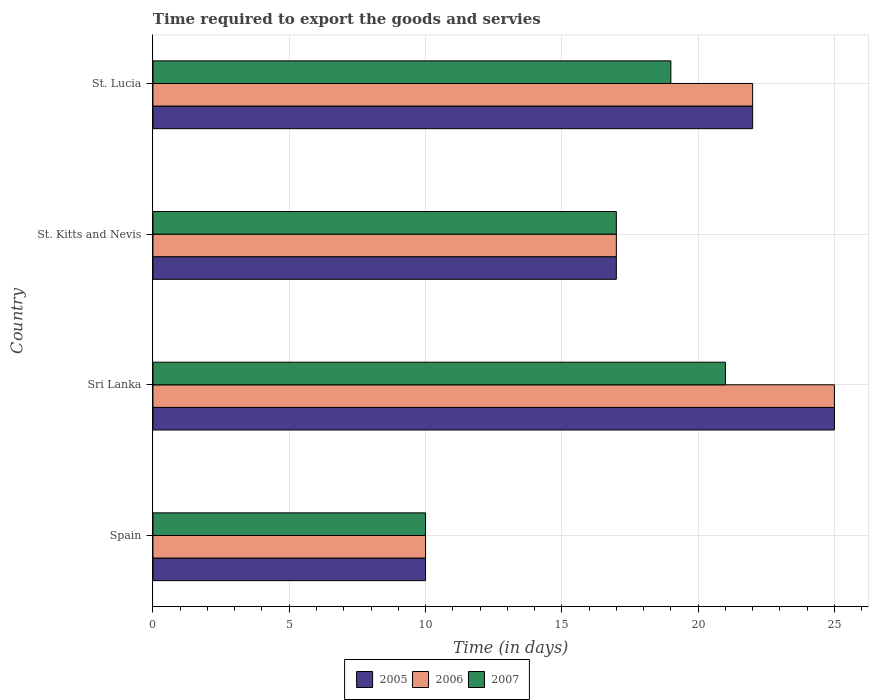How many groups of bars are there?
Keep it short and to the point. 4. Are the number of bars per tick equal to the number of legend labels?
Make the answer very short. Yes. Are the number of bars on each tick of the Y-axis equal?
Your response must be concise. Yes. How many bars are there on the 1st tick from the top?
Offer a terse response. 3. What is the label of the 3rd group of bars from the top?
Your answer should be very brief. Sri Lanka. In how many cases, is the number of bars for a given country not equal to the number of legend labels?
Your answer should be very brief. 0. Across all countries, what is the maximum number of days required to export the goods and services in 2006?
Make the answer very short. 25. Across all countries, what is the minimum number of days required to export the goods and services in 2005?
Provide a short and direct response. 10. In which country was the number of days required to export the goods and services in 2006 maximum?
Your answer should be compact. Sri Lanka. What is the difference between the number of days required to export the goods and services in 2005 in Spain and the number of days required to export the goods and services in 2007 in St. Kitts and Nevis?
Your answer should be compact. -7. What is the average number of days required to export the goods and services in 2005 per country?
Provide a short and direct response. 18.5. What is the difference between the number of days required to export the goods and services in 2006 and number of days required to export the goods and services in 2007 in Sri Lanka?
Provide a succinct answer. 4. In how many countries, is the number of days required to export the goods and services in 2006 greater than 12 days?
Provide a short and direct response. 3. What is the ratio of the number of days required to export the goods and services in 2007 in St. Kitts and Nevis to that in St. Lucia?
Your answer should be compact. 0.89. Is the number of days required to export the goods and services in 2005 in Spain less than that in St. Lucia?
Keep it short and to the point. Yes. What is the difference between the highest and the second highest number of days required to export the goods and services in 2005?
Your answer should be very brief. 3. What is the difference between the highest and the lowest number of days required to export the goods and services in 2005?
Provide a succinct answer. 15. In how many countries, is the number of days required to export the goods and services in 2006 greater than the average number of days required to export the goods and services in 2006 taken over all countries?
Ensure brevity in your answer.  2. Is the sum of the number of days required to export the goods and services in 2007 in Sri Lanka and St. Lucia greater than the maximum number of days required to export the goods and services in 2005 across all countries?
Offer a terse response. Yes. What does the 1st bar from the top in Sri Lanka represents?
Offer a terse response. 2007. What is the difference between two consecutive major ticks on the X-axis?
Your response must be concise. 5. Are the values on the major ticks of X-axis written in scientific E-notation?
Provide a succinct answer. No. What is the title of the graph?
Keep it short and to the point. Time required to export the goods and servies. Does "2012" appear as one of the legend labels in the graph?
Give a very brief answer. No. What is the label or title of the X-axis?
Your response must be concise. Time (in days). What is the label or title of the Y-axis?
Your answer should be compact. Country. What is the Time (in days) in 2005 in Spain?
Your answer should be very brief. 10. What is the Time (in days) of 2006 in Spain?
Your response must be concise. 10. What is the Time (in days) of 2007 in Spain?
Make the answer very short. 10. What is the Time (in days) of 2005 in Sri Lanka?
Make the answer very short. 25. What is the Time (in days) in 2006 in Sri Lanka?
Give a very brief answer. 25. What is the Time (in days) in 2006 in St. Kitts and Nevis?
Provide a short and direct response. 17. What is the Time (in days) in 2006 in St. Lucia?
Keep it short and to the point. 22. What is the Time (in days) of 2007 in St. Lucia?
Ensure brevity in your answer.  19. Across all countries, what is the minimum Time (in days) of 2006?
Your answer should be very brief. 10. Across all countries, what is the minimum Time (in days) of 2007?
Make the answer very short. 10. What is the total Time (in days) of 2005 in the graph?
Provide a short and direct response. 74. What is the total Time (in days) of 2006 in the graph?
Provide a succinct answer. 74. What is the total Time (in days) of 2007 in the graph?
Make the answer very short. 67. What is the difference between the Time (in days) in 2005 in Spain and that in Sri Lanka?
Offer a very short reply. -15. What is the difference between the Time (in days) of 2006 in Spain and that in Sri Lanka?
Give a very brief answer. -15. What is the difference between the Time (in days) of 2005 in Spain and that in St. Kitts and Nevis?
Give a very brief answer. -7. What is the difference between the Time (in days) in 2007 in Spain and that in St. Kitts and Nevis?
Provide a short and direct response. -7. What is the difference between the Time (in days) in 2005 in Spain and that in St. Lucia?
Make the answer very short. -12. What is the difference between the Time (in days) in 2007 in Sri Lanka and that in St. Lucia?
Offer a terse response. 2. What is the difference between the Time (in days) in 2005 in St. Kitts and Nevis and that in St. Lucia?
Your answer should be very brief. -5. What is the difference between the Time (in days) of 2006 in St. Kitts and Nevis and that in St. Lucia?
Keep it short and to the point. -5. What is the difference between the Time (in days) of 2005 in Spain and the Time (in days) of 2006 in Sri Lanka?
Offer a terse response. -15. What is the difference between the Time (in days) in 2005 in Spain and the Time (in days) in 2006 in St. Kitts and Nevis?
Provide a short and direct response. -7. What is the difference between the Time (in days) of 2005 in Spain and the Time (in days) of 2007 in St. Kitts and Nevis?
Provide a short and direct response. -7. What is the difference between the Time (in days) in 2006 in Spain and the Time (in days) in 2007 in St. Kitts and Nevis?
Make the answer very short. -7. What is the difference between the Time (in days) in 2005 in Spain and the Time (in days) in 2006 in St. Lucia?
Give a very brief answer. -12. What is the difference between the Time (in days) of 2005 in Spain and the Time (in days) of 2007 in St. Lucia?
Your answer should be compact. -9. What is the difference between the Time (in days) in 2006 in Spain and the Time (in days) in 2007 in St. Lucia?
Provide a short and direct response. -9. What is the difference between the Time (in days) of 2005 in Sri Lanka and the Time (in days) of 2007 in St. Kitts and Nevis?
Your response must be concise. 8. What is the difference between the Time (in days) in 2005 in Sri Lanka and the Time (in days) in 2007 in St. Lucia?
Your response must be concise. 6. What is the difference between the Time (in days) of 2005 in St. Kitts and Nevis and the Time (in days) of 2006 in St. Lucia?
Make the answer very short. -5. What is the difference between the Time (in days) in 2005 in St. Kitts and Nevis and the Time (in days) in 2007 in St. Lucia?
Offer a very short reply. -2. What is the average Time (in days) in 2005 per country?
Give a very brief answer. 18.5. What is the average Time (in days) of 2006 per country?
Your response must be concise. 18.5. What is the average Time (in days) in 2007 per country?
Your response must be concise. 16.75. What is the difference between the Time (in days) in 2005 and Time (in days) in 2006 in Spain?
Your answer should be compact. 0. What is the difference between the Time (in days) of 2005 and Time (in days) of 2007 in Spain?
Provide a short and direct response. 0. What is the difference between the Time (in days) of 2006 and Time (in days) of 2007 in Spain?
Ensure brevity in your answer.  0. What is the difference between the Time (in days) of 2005 and Time (in days) of 2007 in Sri Lanka?
Give a very brief answer. 4. What is the difference between the Time (in days) in 2006 and Time (in days) in 2007 in Sri Lanka?
Give a very brief answer. 4. What is the difference between the Time (in days) of 2005 and Time (in days) of 2007 in St. Kitts and Nevis?
Keep it short and to the point. 0. What is the difference between the Time (in days) of 2006 and Time (in days) of 2007 in St. Kitts and Nevis?
Keep it short and to the point. 0. What is the difference between the Time (in days) of 2005 and Time (in days) of 2006 in St. Lucia?
Ensure brevity in your answer.  0. What is the ratio of the Time (in days) of 2007 in Spain to that in Sri Lanka?
Make the answer very short. 0.48. What is the ratio of the Time (in days) in 2005 in Spain to that in St. Kitts and Nevis?
Your response must be concise. 0.59. What is the ratio of the Time (in days) of 2006 in Spain to that in St. Kitts and Nevis?
Ensure brevity in your answer.  0.59. What is the ratio of the Time (in days) in 2007 in Spain to that in St. Kitts and Nevis?
Ensure brevity in your answer.  0.59. What is the ratio of the Time (in days) of 2005 in Spain to that in St. Lucia?
Provide a short and direct response. 0.45. What is the ratio of the Time (in days) in 2006 in Spain to that in St. Lucia?
Make the answer very short. 0.45. What is the ratio of the Time (in days) in 2007 in Spain to that in St. Lucia?
Ensure brevity in your answer.  0.53. What is the ratio of the Time (in days) in 2005 in Sri Lanka to that in St. Kitts and Nevis?
Your answer should be very brief. 1.47. What is the ratio of the Time (in days) of 2006 in Sri Lanka to that in St. Kitts and Nevis?
Make the answer very short. 1.47. What is the ratio of the Time (in days) of 2007 in Sri Lanka to that in St. Kitts and Nevis?
Your response must be concise. 1.24. What is the ratio of the Time (in days) of 2005 in Sri Lanka to that in St. Lucia?
Keep it short and to the point. 1.14. What is the ratio of the Time (in days) of 2006 in Sri Lanka to that in St. Lucia?
Your response must be concise. 1.14. What is the ratio of the Time (in days) in 2007 in Sri Lanka to that in St. Lucia?
Ensure brevity in your answer.  1.11. What is the ratio of the Time (in days) of 2005 in St. Kitts and Nevis to that in St. Lucia?
Offer a very short reply. 0.77. What is the ratio of the Time (in days) of 2006 in St. Kitts and Nevis to that in St. Lucia?
Provide a short and direct response. 0.77. What is the ratio of the Time (in days) in 2007 in St. Kitts and Nevis to that in St. Lucia?
Your answer should be very brief. 0.89. What is the difference between the highest and the second highest Time (in days) in 2005?
Your response must be concise. 3. What is the difference between the highest and the second highest Time (in days) of 2007?
Provide a short and direct response. 2. What is the difference between the highest and the lowest Time (in days) in 2006?
Your response must be concise. 15. 